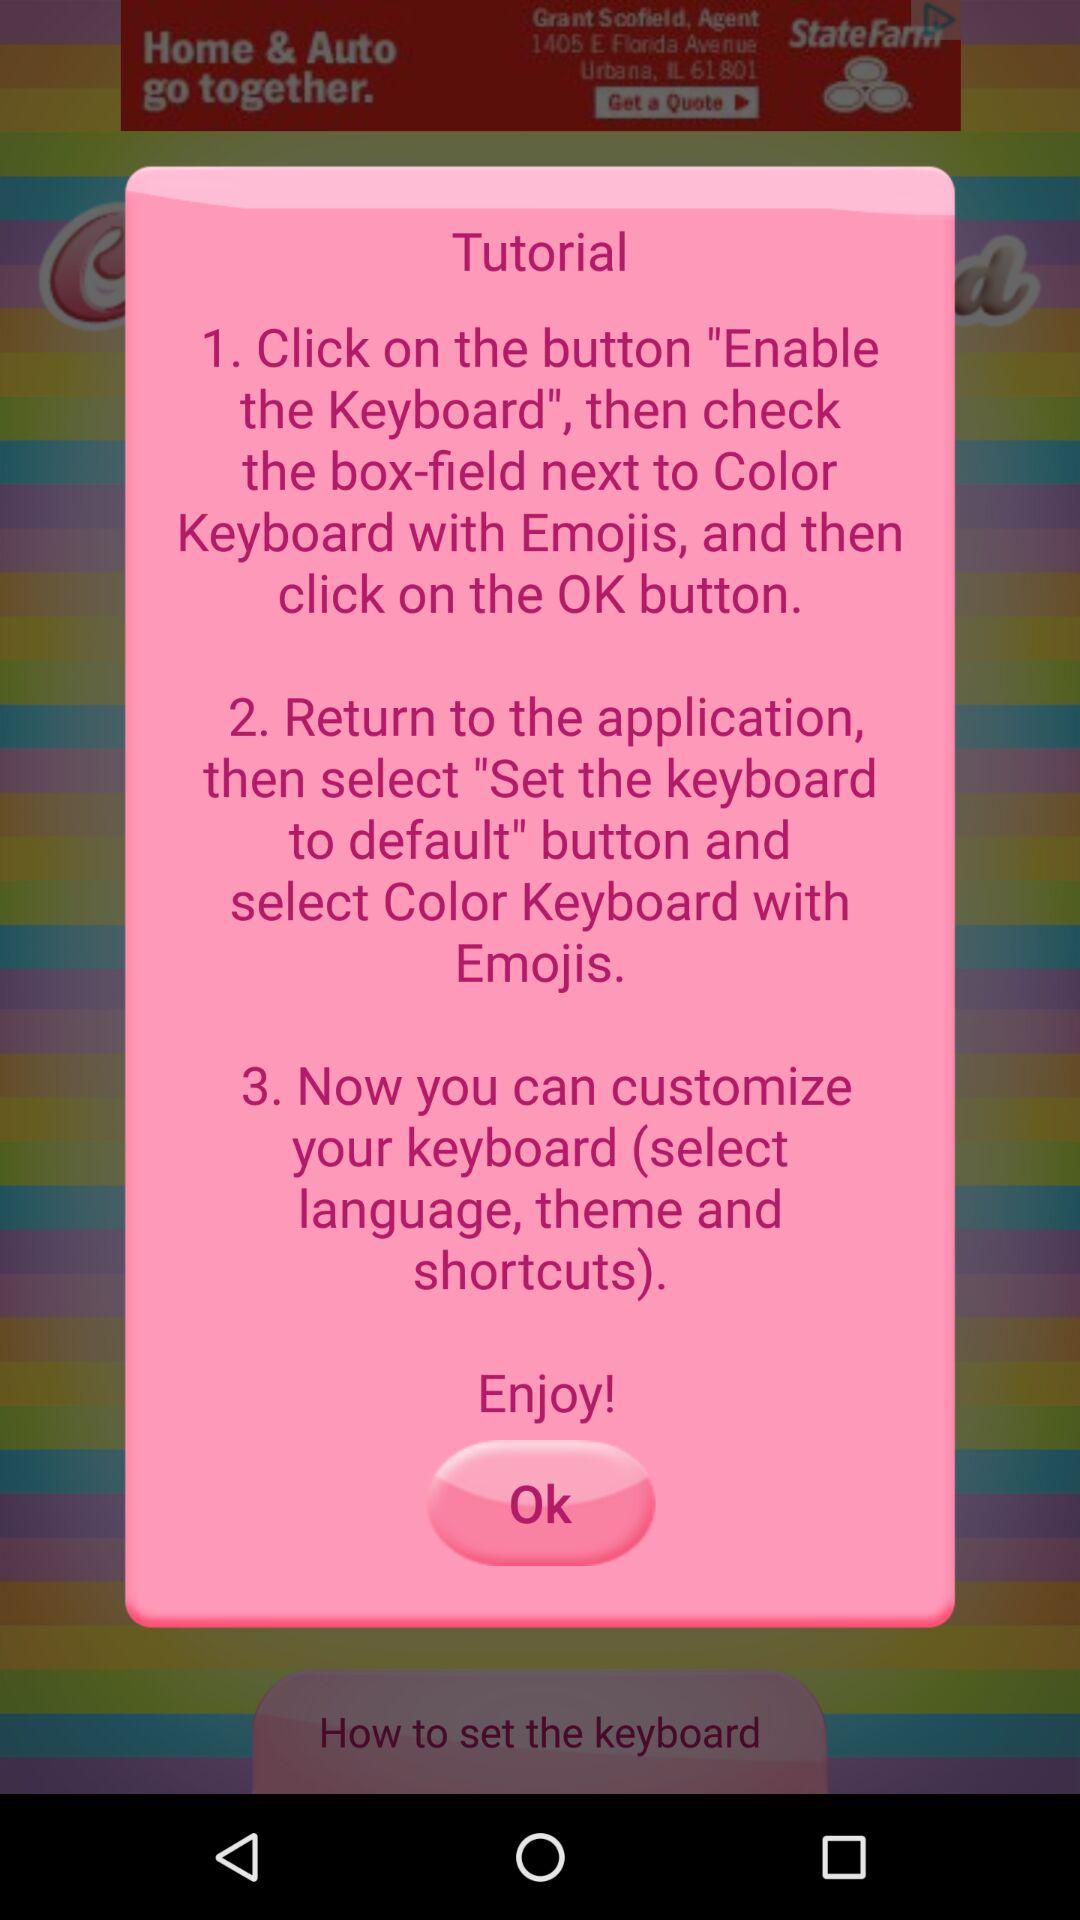How many steps are in the tutorial?
Answer the question using a single word or phrase. 3 